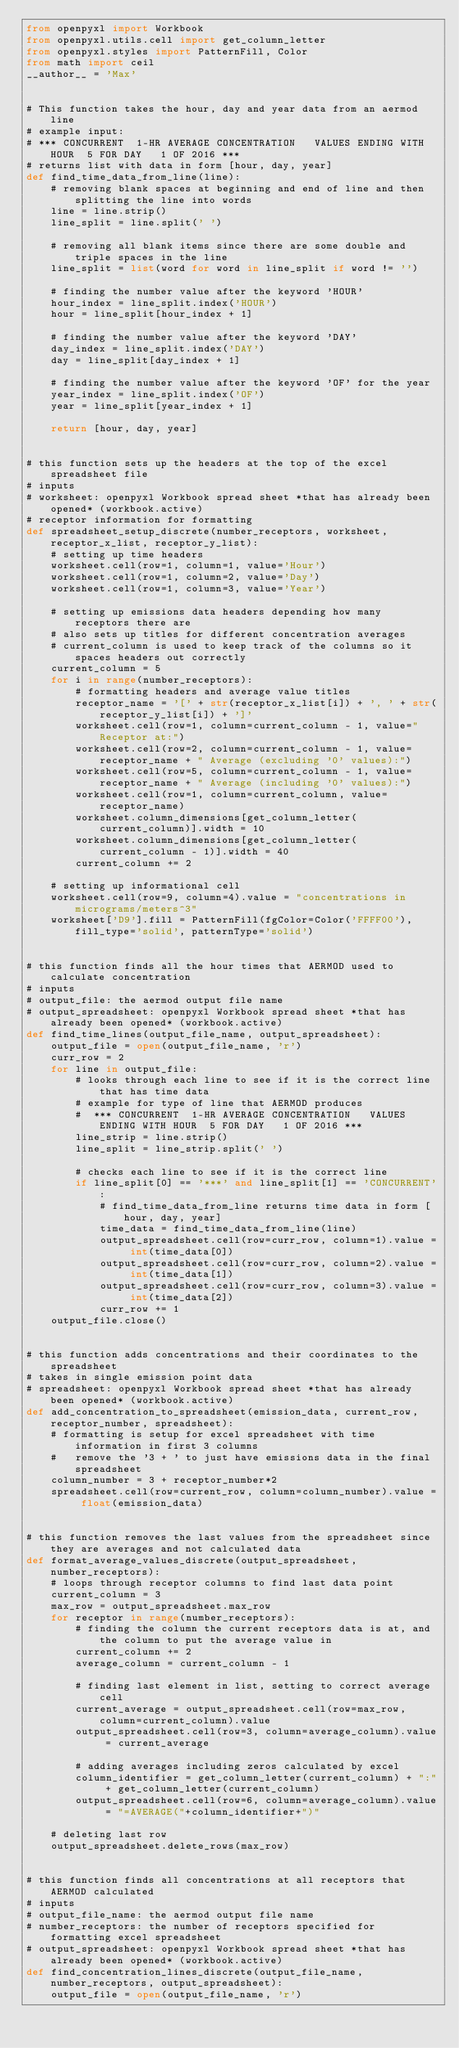<code> <loc_0><loc_0><loc_500><loc_500><_Python_>from openpyxl import Workbook
from openpyxl.utils.cell import get_column_letter
from openpyxl.styles import PatternFill, Color
from math import ceil
__author__ = 'Max'


# This function takes the hour, day and year data from an aermod line
# example input:
# *** CONCURRENT  1-HR AVERAGE CONCENTRATION   VALUES ENDING WITH HOUR  5 FOR DAY   1 OF 2016 ***
# returns list with data in form [hour, day, year]
def find_time_data_from_line(line):
    # removing blank spaces at beginning and end of line and then splitting the line into words
    line = line.strip()
    line_split = line.split(' ')

    # removing all blank items since there are some double and triple spaces in the line
    line_split = list(word for word in line_split if word != '')

    # finding the number value after the keyword 'HOUR'
    hour_index = line_split.index('HOUR')
    hour = line_split[hour_index + 1]

    # finding the number value after the keyword 'DAY'
    day_index = line_split.index('DAY')
    day = line_split[day_index + 1]

    # finding the number value after the keyword 'OF' for the year
    year_index = line_split.index('OF')
    year = line_split[year_index + 1]

    return [hour, day, year]


# this function sets up the headers at the top of the excel spreadsheet file
# inputs
# worksheet: openpyxl Workbook spread sheet *that has already been opened* (workbook.active)
# receptor information for formatting
def spreadsheet_setup_discrete(number_receptors, worksheet, receptor_x_list, receptor_y_list):
    # setting up time headers
    worksheet.cell(row=1, column=1, value='Hour')
    worksheet.cell(row=1, column=2, value='Day')
    worksheet.cell(row=1, column=3, value='Year')

    # setting up emissions data headers depending how many receptors there are
    # also sets up titles for different concentration averages
    # current_column is used to keep track of the columns so it spaces headers out correctly
    current_column = 5
    for i in range(number_receptors):
        # formatting headers and average value titles
        receptor_name = '[' + str(receptor_x_list[i]) + ', ' + str(receptor_y_list[i]) + ']'
        worksheet.cell(row=1, column=current_column - 1, value="Receptor at:")
        worksheet.cell(row=2, column=current_column - 1, value=receptor_name + " Average (excluding '0' values):")
        worksheet.cell(row=5, column=current_column - 1, value=receptor_name + " Average (including '0' values):")
        worksheet.cell(row=1, column=current_column, value=receptor_name)
        worksheet.column_dimensions[get_column_letter(current_column)].width = 10
        worksheet.column_dimensions[get_column_letter(current_column - 1)].width = 40
        current_column += 2

    # setting up informational cell
    worksheet.cell(row=9, column=4).value = "concentrations in micrograms/meters^3"
    worksheet['D9'].fill = PatternFill(fgColor=Color('FFFF00'), fill_type='solid', patternType='solid')


# this function finds all the hour times that AERMOD used to calculate concentration
# inputs
# output_file: the aermod output file name
# output_spreadsheet: openpyxl Workbook spread sheet *that has already been opened* (workbook.active)
def find_time_lines(output_file_name, output_spreadsheet):
    output_file = open(output_file_name, 'r')
    curr_row = 2
    for line in output_file:
        # looks through each line to see if it is the correct line that has time data
        # example for type of line that AERMOD produces
        #  *** CONCURRENT  1-HR AVERAGE CONCENTRATION   VALUES ENDING WITH HOUR  5 FOR DAY   1 OF 2016 ***
        line_strip = line.strip()
        line_split = line_strip.split(' ')

        # checks each line to see if it is the correct line
        if line_split[0] == '***' and line_split[1] == 'CONCURRENT':
            # find_time_data_from_line returns time data in form [hour, day, year]
            time_data = find_time_data_from_line(line)
            output_spreadsheet.cell(row=curr_row, column=1).value = int(time_data[0])
            output_spreadsheet.cell(row=curr_row, column=2).value = int(time_data[1])
            output_spreadsheet.cell(row=curr_row, column=3).value = int(time_data[2])
            curr_row += 1
    output_file.close()


# this function adds concentrations and their coordinates to the spreadsheet
# takes in single emission point data
# spreadsheet: openpyxl Workbook spread sheet *that has already been opened* (workbook.active)
def add_concentration_to_spreadsheet(emission_data, current_row, receptor_number, spreadsheet):
    # formatting is setup for excel spreadsheet with time information in first 3 columns
    #   remove the '3 + ' to just have emissions data in the final spreadsheet
    column_number = 3 + receptor_number*2
    spreadsheet.cell(row=current_row, column=column_number).value = float(emission_data)


# this function removes the last values from the spreadsheet since they are averages and not calculated data
def format_average_values_discrete(output_spreadsheet, number_receptors):
    # loops through receptor columns to find last data point
    current_column = 3
    max_row = output_spreadsheet.max_row
    for receptor in range(number_receptors):
        # finding the column the current receptors data is at, and the column to put the average value in
        current_column += 2
        average_column = current_column - 1

        # finding last element in list, setting to correct average cell
        current_average = output_spreadsheet.cell(row=max_row, column=current_column).value
        output_spreadsheet.cell(row=3, column=average_column).value = current_average

        # adding averages including zeros calculated by excel
        column_identifier = get_column_letter(current_column) + ":" + get_column_letter(current_column)
        output_spreadsheet.cell(row=6, column=average_column).value = "=AVERAGE("+column_identifier+")"

    # deleting last row
    output_spreadsheet.delete_rows(max_row)


# this function finds all concentrations at all receptors that AERMOD calculated
# inputs
# output_file_name: the aermod output file name
# number_receptors: the number of receptors specified for formatting excel spreadsheet
# output_spreadsheet: openpyxl Workbook spread sheet *that has already been opened* (workbook.active)
def find_concentration_lines_discrete(output_file_name, number_receptors, output_spreadsheet):
    output_file = open(output_file_name, 'r')</code> 